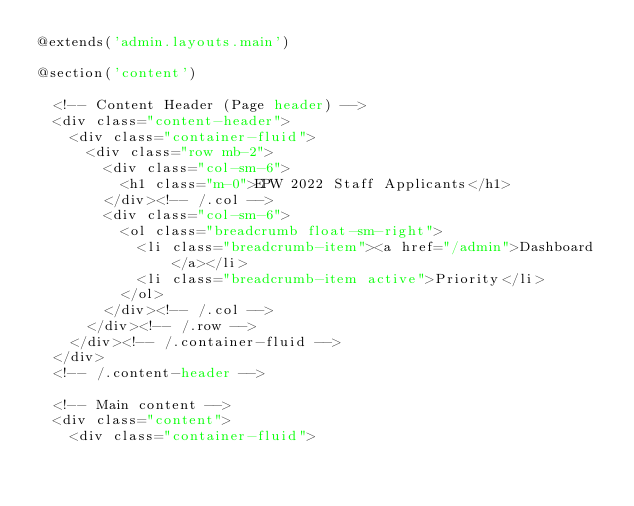<code> <loc_0><loc_0><loc_500><loc_500><_PHP_>@extends('admin.layouts.main')

@section('content')
    
  <!-- Content Header (Page header) -->
  <div class="content-header">
    <div class="container-fluid">
      <div class="row mb-2">
        <div class="col-sm-6">
          <h1 class="m-0">EPW 2022 Staff Applicants</h1>
        </div><!-- /.col -->
        <div class="col-sm-6">
          <ol class="breadcrumb float-sm-right">
            <li class="breadcrumb-item"><a href="/admin">Dashboard</a></li>
            <li class="breadcrumb-item active">Priority</li>
          </ol>
        </div><!-- /.col -->
      </div><!-- /.row -->
    </div><!-- /.container-fluid -->
  </div>
  <!-- /.content-header -->

  <!-- Main content -->
  <div class="content">
    <div class="container-fluid"></code> 